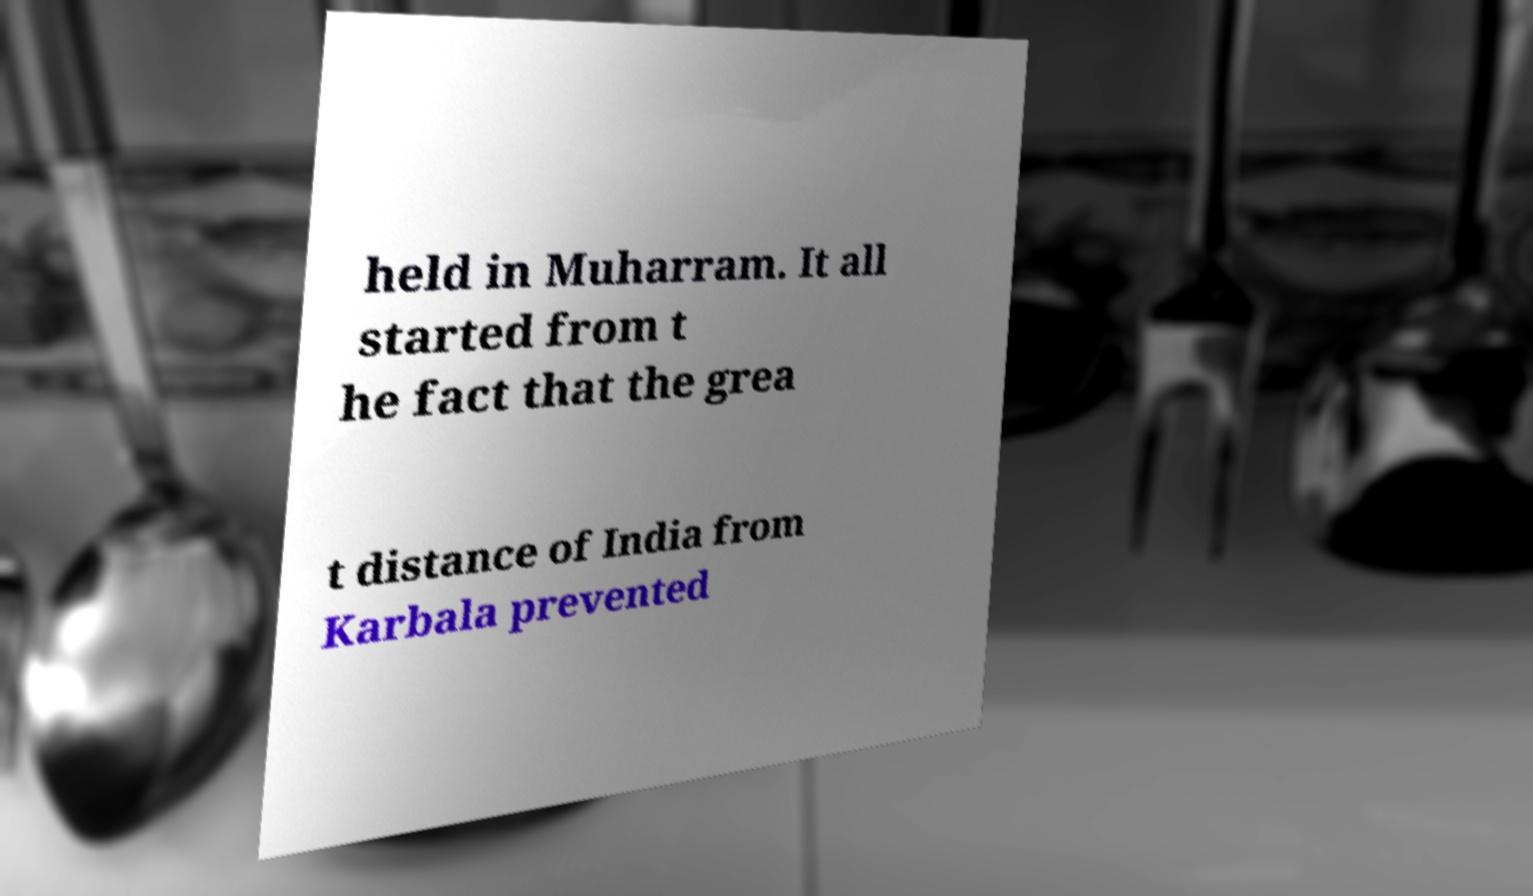There's text embedded in this image that I need extracted. Can you transcribe it verbatim? held in Muharram. It all started from t he fact that the grea t distance of India from Karbala prevented 